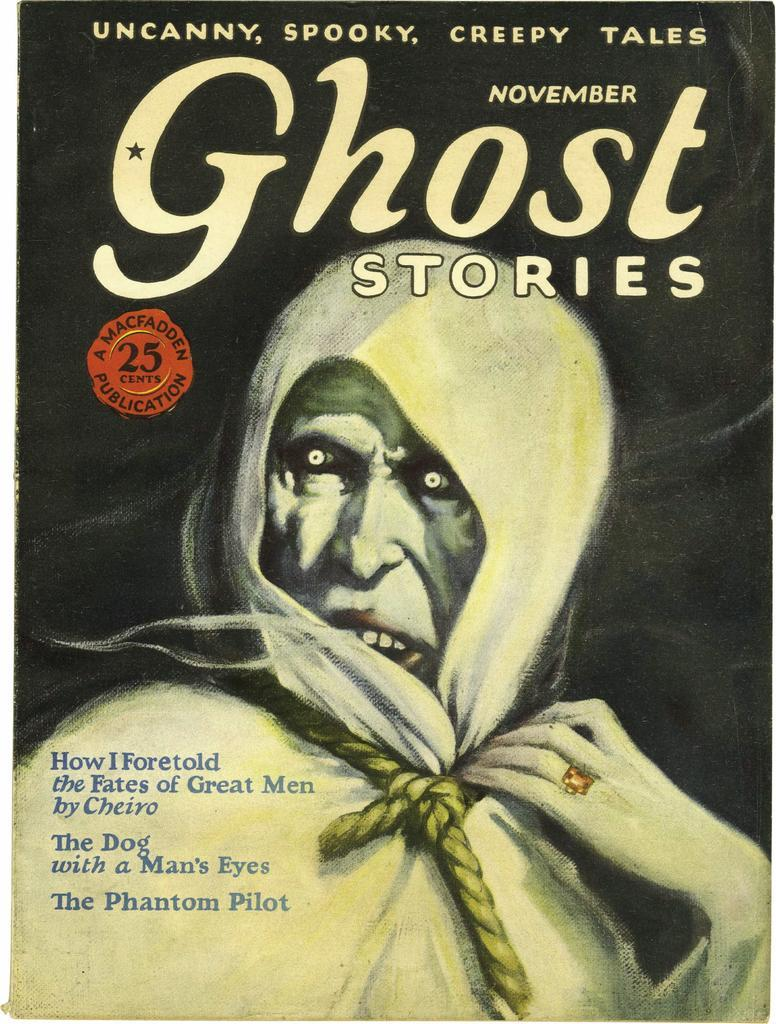What is present on the poster in the image? There is a poster in the image, which contains an image of a person. What else can be found on the poster besides the image? There is text on the poster. What type of animal can be seen in the clouds above the poster in the image? There are no clouds or animals present in the image; it only features a poster with an image of a person and text. 